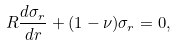<formula> <loc_0><loc_0><loc_500><loc_500>R \frac { d \sigma _ { r } } { d r } + ( 1 - \nu ) \sigma _ { r } = 0 ,</formula> 